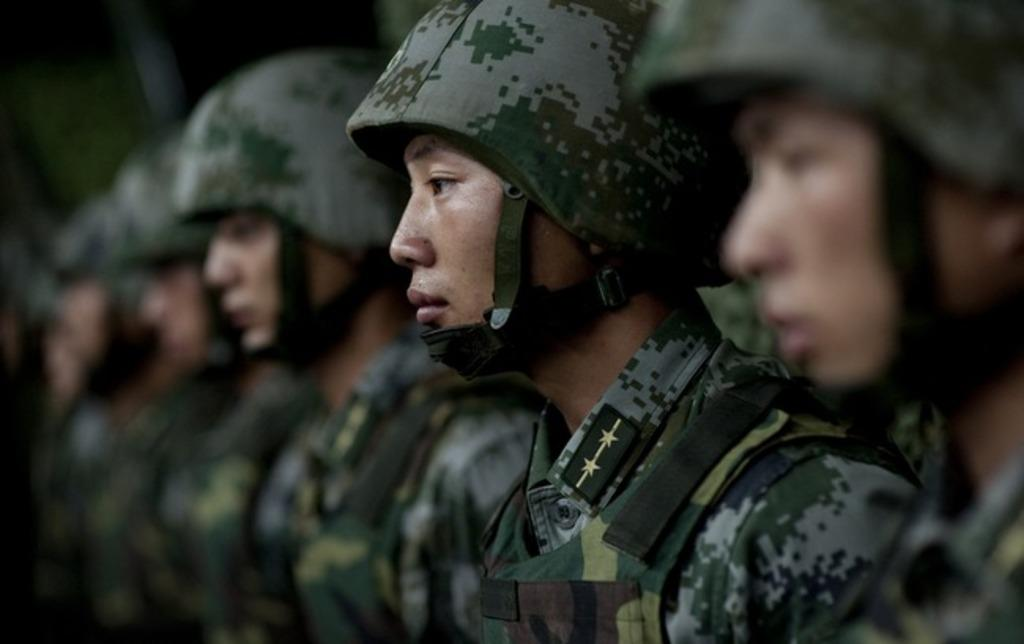What is the main subject of the image? The main subject of the image is a group of men. What are the men wearing in the image? The men are wearing helmets in the image. What type of bucket is being used by the men in the image? There is no bucket present in the image. What is the opinion of the men about the vase in the image? There is no vase present in the image, so it is not possible to determine their opinion about it. 